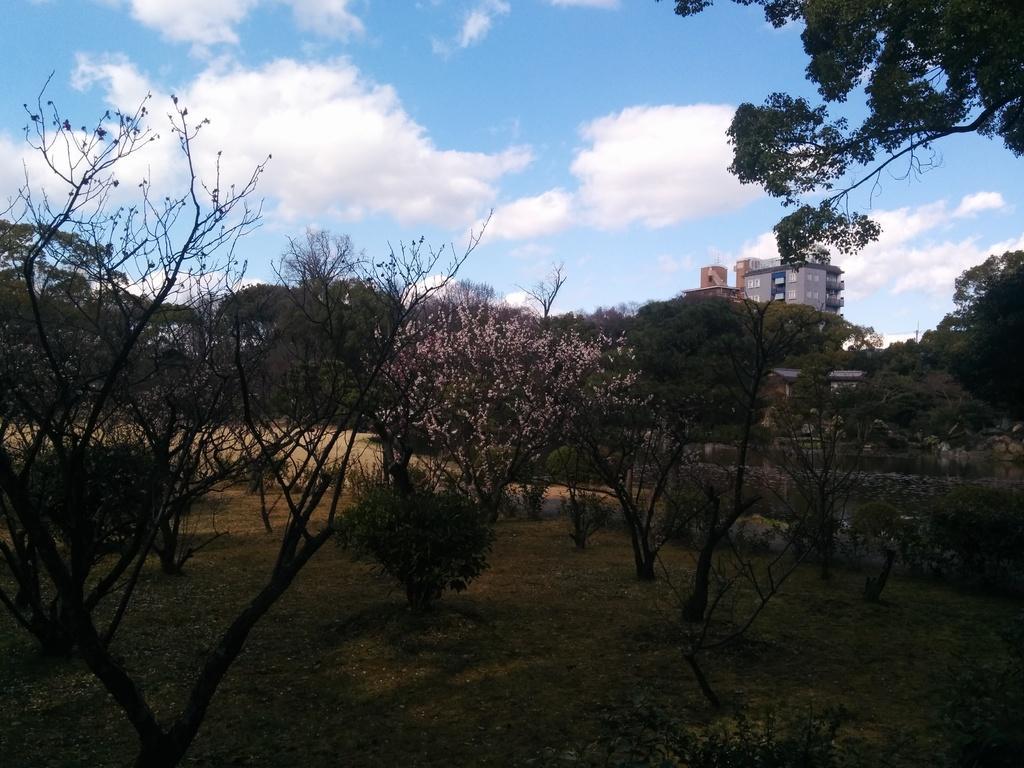Describe this image in one or two sentences. This image is taken outdoors. At the bottom of the image there is a ground with grass, many plants and trees on it. In the background there is a building. At the top of the image there is a sky with clouds. 